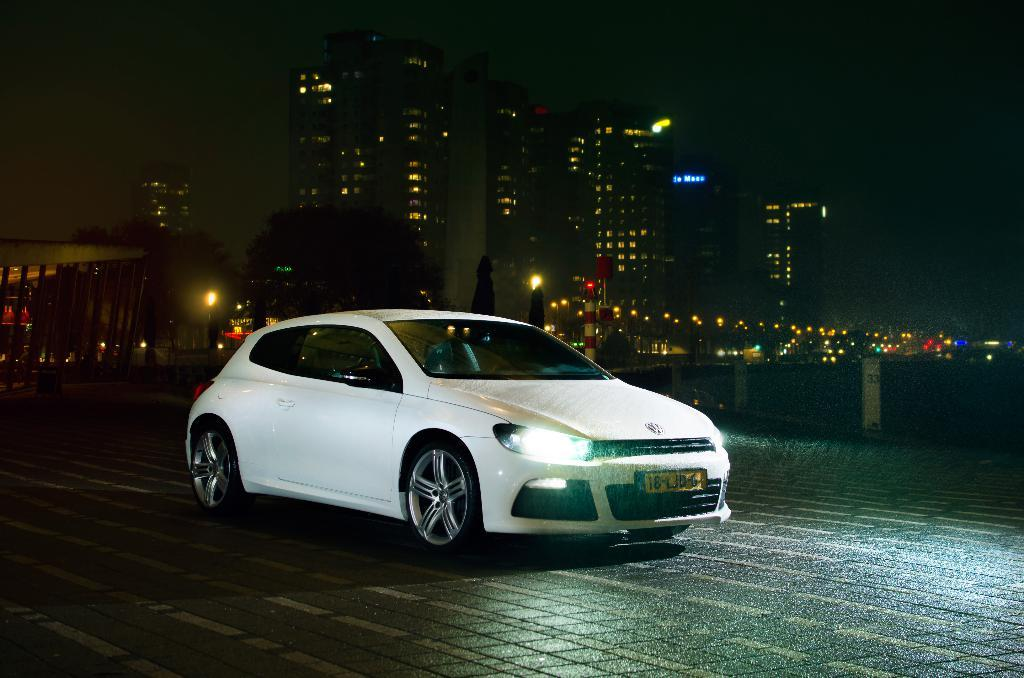What is the main subject of the image? There is a car in the image. What color is the car? The car is white in color. What is the car doing in the image? The car is moving on the road. What can be seen in the background of the image? There are buildings in the background of the image. What type of lights are visible in the image? There are lights visible in the image. What type of soup is being cooked in the car's engine in the image? There is no soup or cooking activity present in the image; it features a moving white car on the road with buildings in the background and lights visible. 